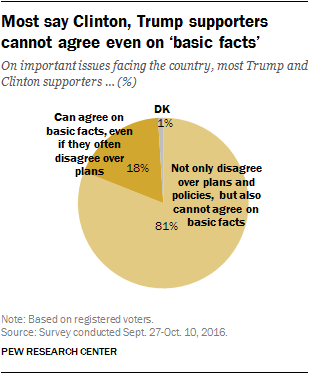Specify some key components in this picture. The largest segment is larger than the sum of the two smallest segments, equal to 62. 